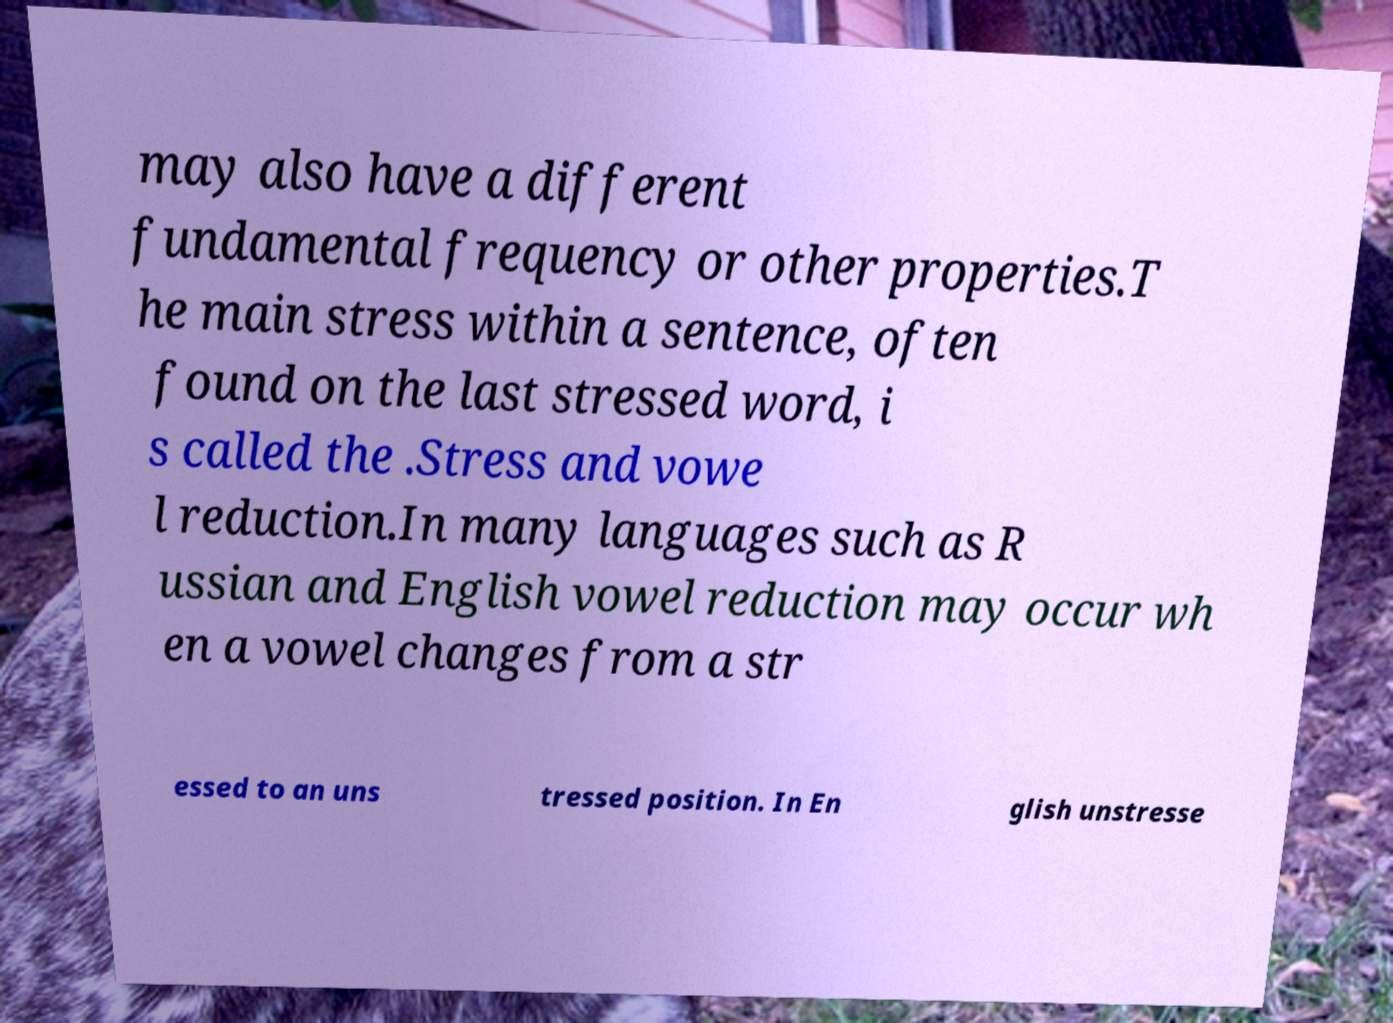Please read and relay the text visible in this image. What does it say? may also have a different fundamental frequency or other properties.T he main stress within a sentence, often found on the last stressed word, i s called the .Stress and vowe l reduction.In many languages such as R ussian and English vowel reduction may occur wh en a vowel changes from a str essed to an uns tressed position. In En glish unstresse 